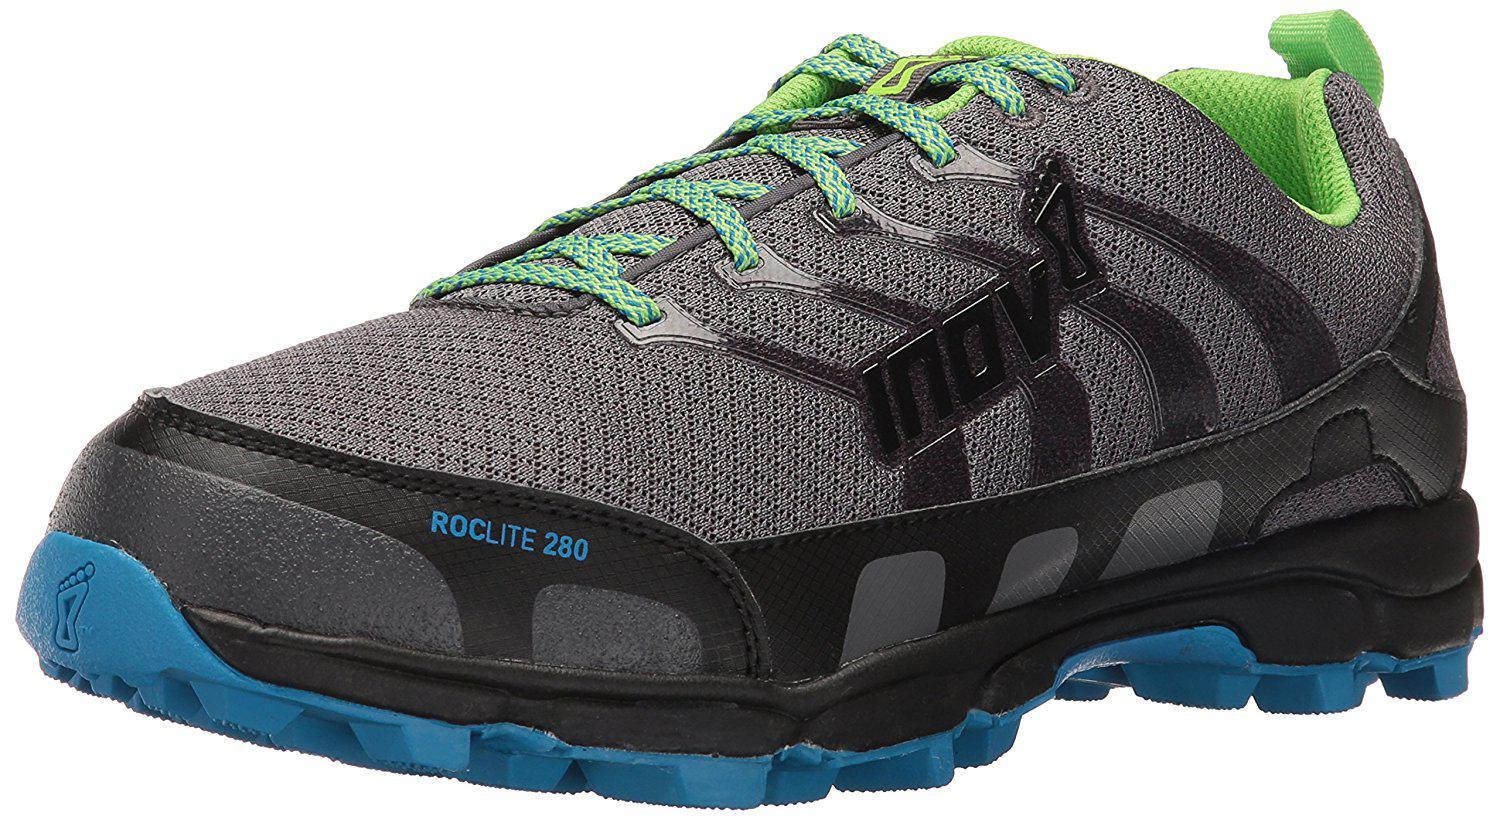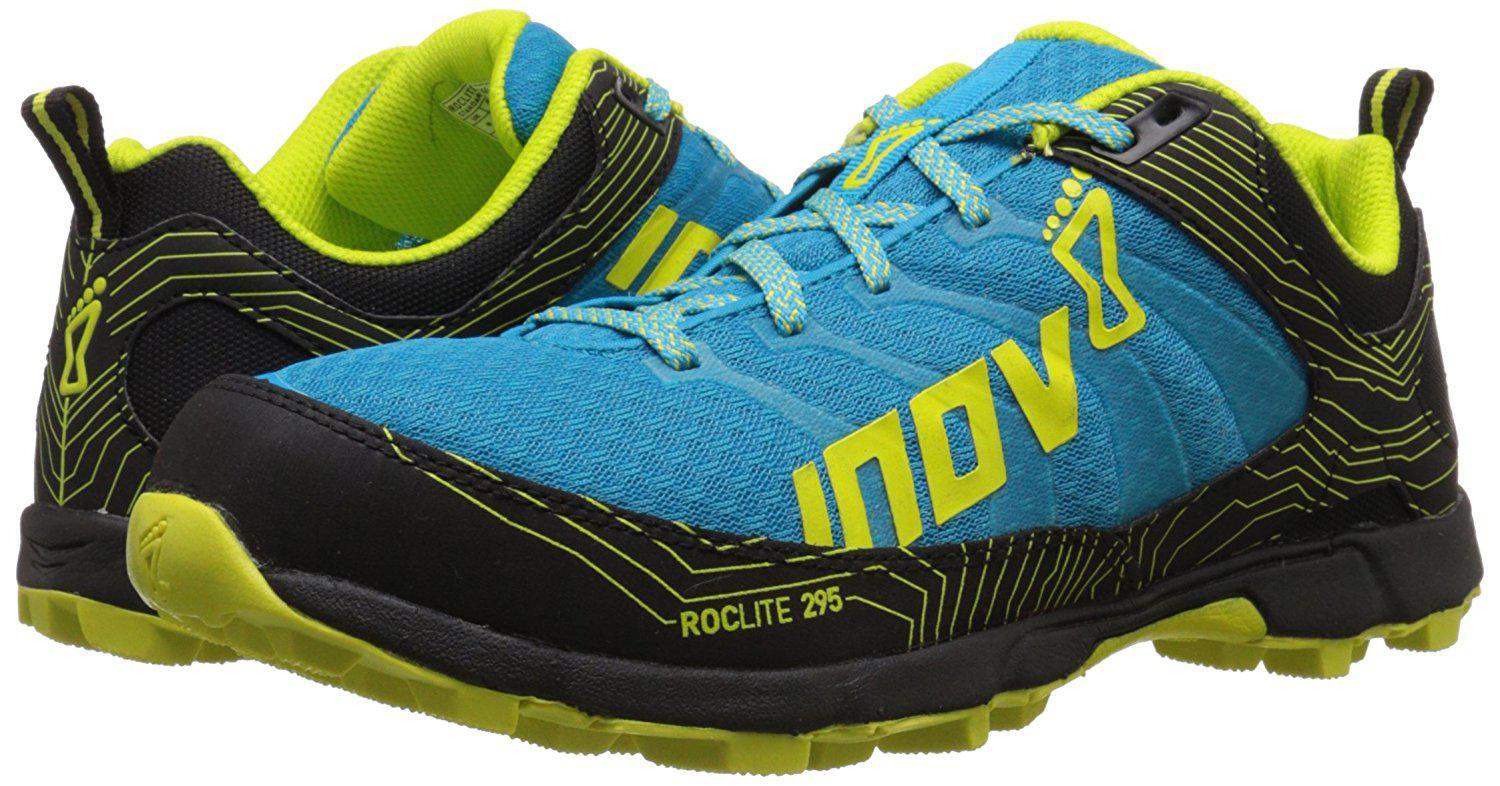The first image is the image on the left, the second image is the image on the right. Given the left and right images, does the statement "The left image contains one leftward angled sneaker, and the right image contains a pair of sneakers posed side-by-side heel-to-toe." hold true? Answer yes or no. Yes. The first image is the image on the left, the second image is the image on the right. Given the left and right images, does the statement "In one image, a pair of shoes has one shoe facing forward and one facing backward, the color of the shoe soles matching the inside fabric." hold true? Answer yes or no. Yes. 